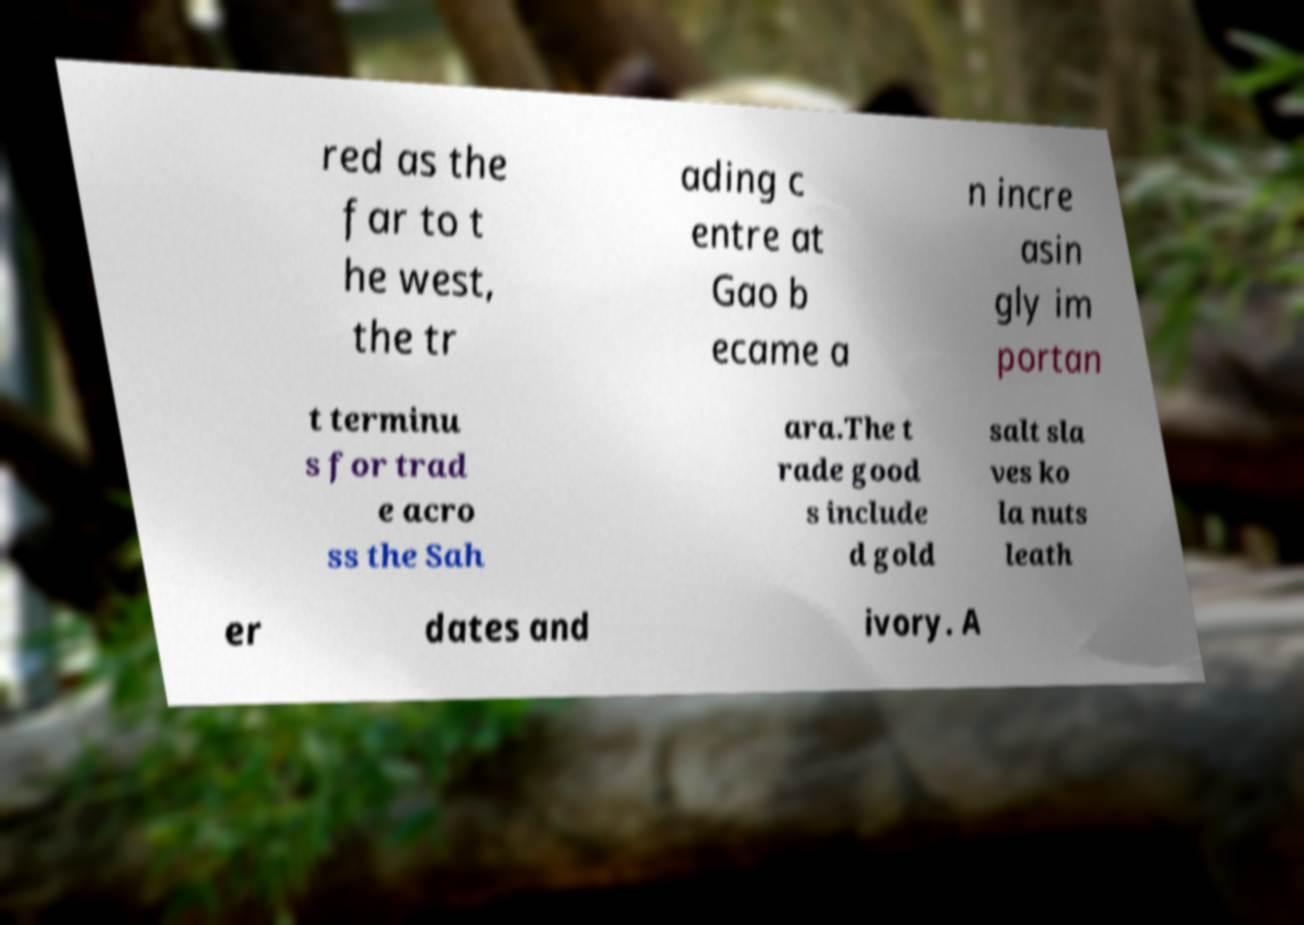Please identify and transcribe the text found in this image. red as the far to t he west, the tr ading c entre at Gao b ecame a n incre asin gly im portan t terminu s for trad e acro ss the Sah ara.The t rade good s include d gold salt sla ves ko la nuts leath er dates and ivory. A 